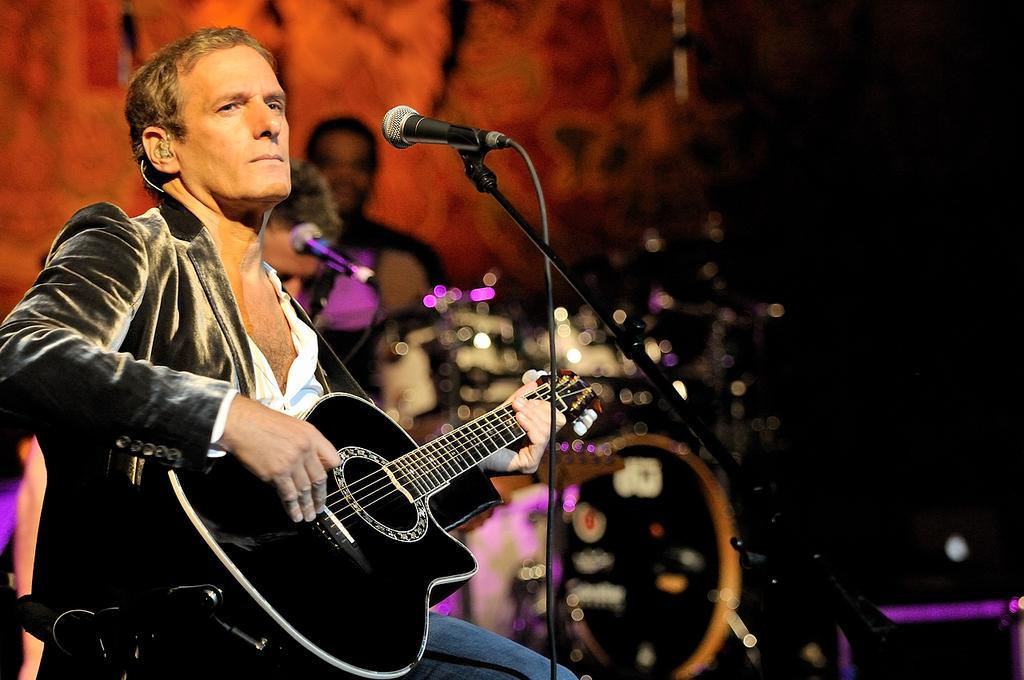What is the person in the image doing? The person is sitting and playing the guitar in the image. What instrument is the person holding? The person is holding a guitar. What equipment is in front of the person? There is a microphone and a microphone stand in front of the person. What can be seen in the background of the image? There is a drum, a light, and other persons in the background of the image. What type of sleet can be seen falling on the drum in the background of the image? There is no sleet present in the image, and the drum is not being affected by any weather conditions. How many wings are visible on the person playing the guitar? The person playing the guitar does not have any visible wings, as they are a human playing a musical instrument. 